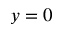<formula> <loc_0><loc_0><loc_500><loc_500>y = 0</formula> 